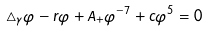<formula> <loc_0><loc_0><loc_500><loc_500>\triangle _ { \gamma } \varphi - r \varphi + A _ { + } \varphi ^ { - 7 } + c \varphi ^ { 5 } = 0</formula> 